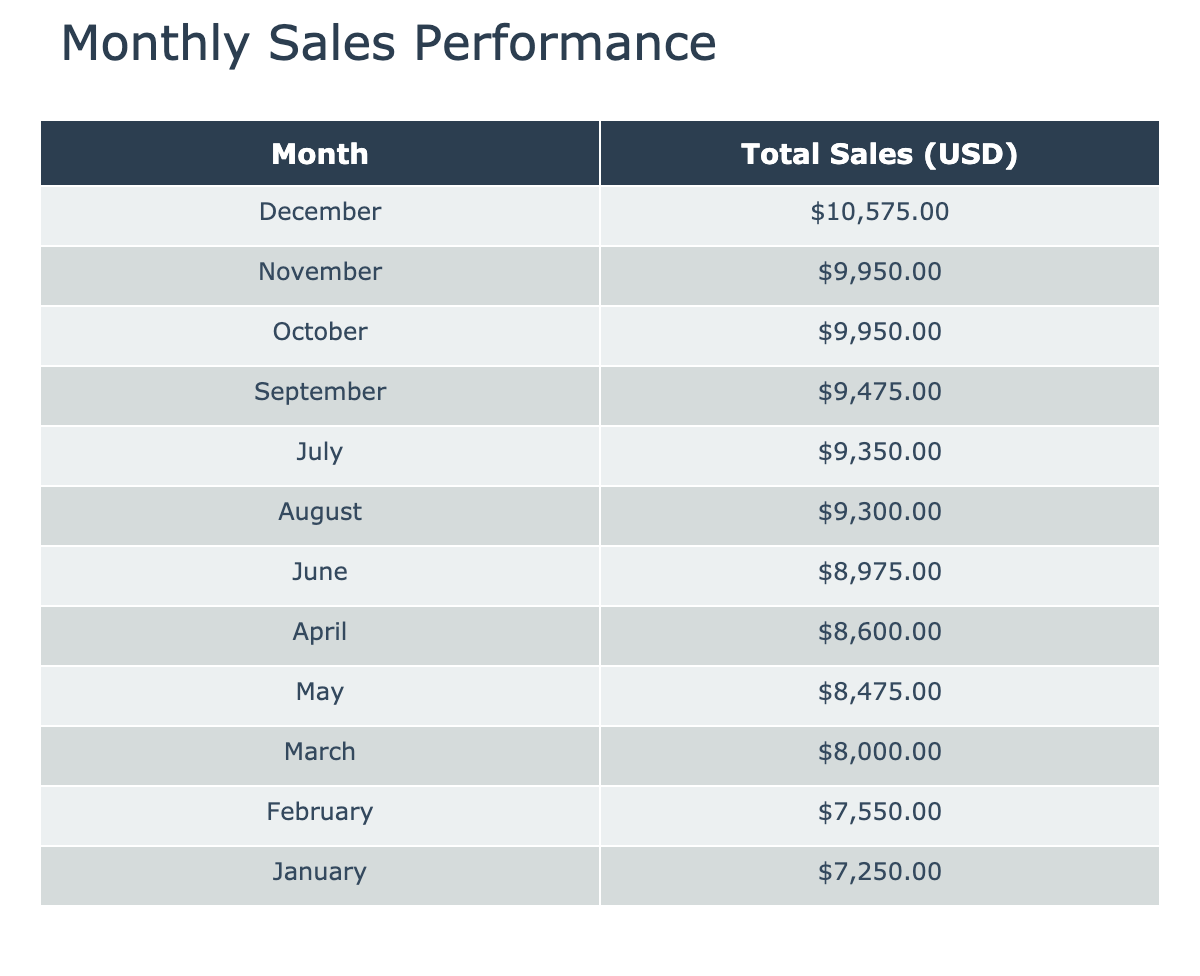What was the total sales for Resistance Bands in December? From the table, for December, the Total Sales for Resistance Bands is listed as $3000.
Answer: $3000 Which month had the highest total sales? By observing the total sales in the table, December has the highest total sales amounting to $10,575.
Answer: December What is the average total sales for Therapy Balls across all months? The total sales for Therapy Balls by month are: $2000, $2200, $2100, $2300, $2400, $2500, $2600, $2800, $2700, $2900, $3000, and $3200, which sums up to $29,900. There are 12 months, so the average is $29,900 / 12 = $2,491.67.
Answer: $2,491.67 Did Ankle Weights sales ever exceed $4,000? By examining the data, Ankle Weights sales exceeded $4,000 in November ($4,250) and December ($4,375)
Answer: Yes What was the total sales difference between April and May? The total sales for April is $10,050 (from adding $3750, $2300, and $2550), and for May, it's $8,475 ($3375, $2400, and $2700), so the difference is $10,050 - $8,475 = $1,575.
Answer: $1,575 What percentage of total sales in September came from Ankle Weights? In September, the total sales sum $6,475 (Resistance Bands $2,775, Therapy Balls $2,700, Ankle Weights $4,000), with Ankle Weights at $4,000. The percentage is ($4,000 / $6,475) * 100 = 61.76%.
Answer: 61.76% What was the total sales for all products in July? In July, Resistance Bands sold $3,000, Therapy Balls $2,600, and Ankle Weights $3,750, giving a total of $3,000 + $2,600 + $3,750 = $9,350 for July.
Answer: $9,350 Which product had the most significant sales drop from one month to the next? Examining the sales month-on-month shows Therapy Balls sales dropped from $3,200 in December to $2,600 in July, a drop of $600. However, the most substantial monthly drop was in Resistance Bands from December $3,000 to January $2,250, which is a $750 drop.
Answer: Resistance Bands What was the total revenue from Ankle Weights for the first half of the year? Total Ankle Weights sales for months January to June are: $3,000, $3,250, $3,500, $3,750, $3,375, and $3,625, which totals to $3,000 + $3,250 + $3,500 + $3,750 + $3,375 + $3,625 = $20,500.
Answer: $20,500 